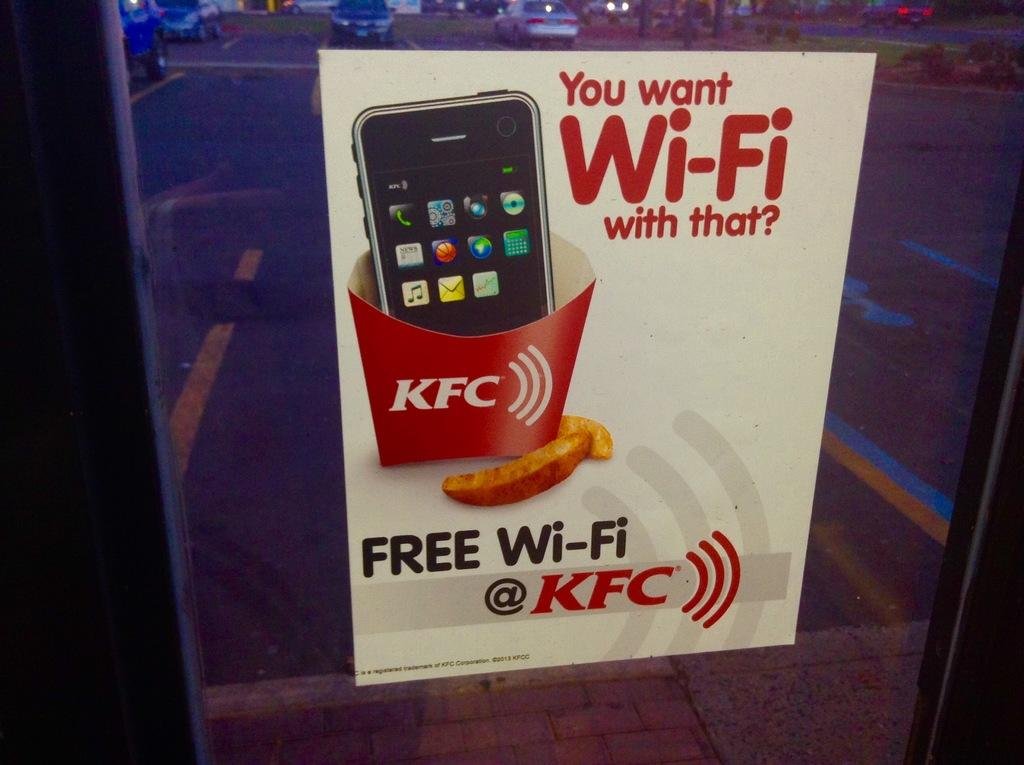<image>
Describe the image concisely. A box claiming free wi-fi with the KFC logos and you want wi-fi with that 